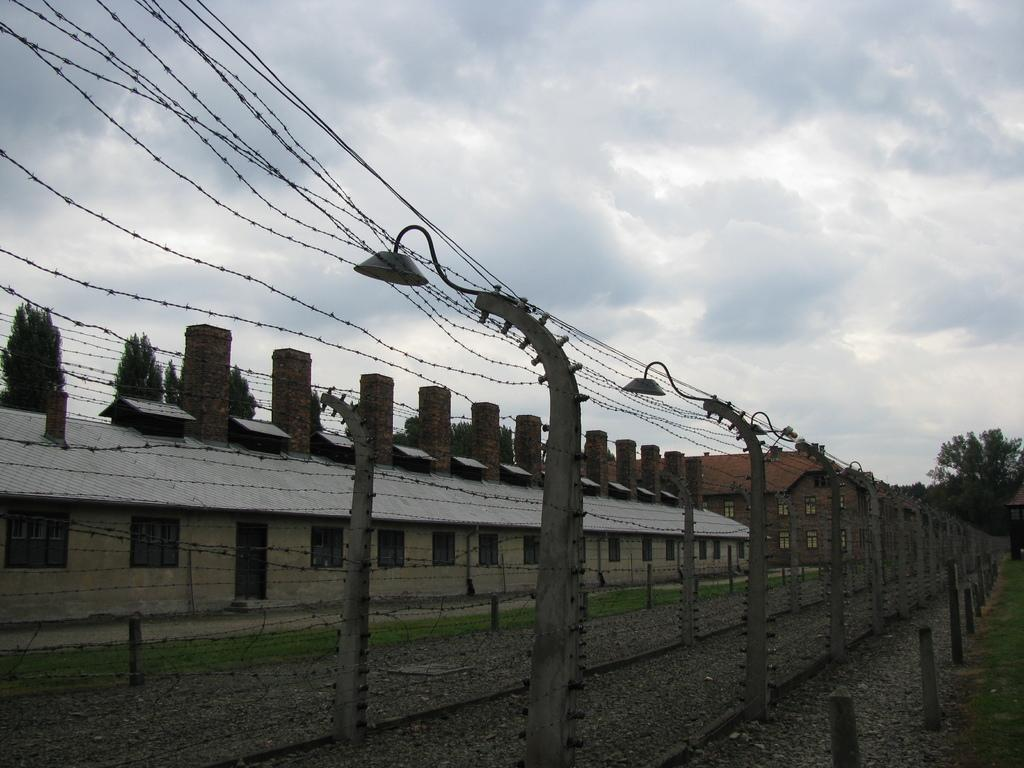What type of structure can be seen in the image? There is a fence in the image. What else can be seen in the image besides the fence? There are light poles, buildings, trees, and the sky visible in the image. Can you describe the objects on the ground in the background of the image? There are other objects on the ground in the background of the image, but their specific details are not mentioned in the provided facts. What does the mom think about the print in the image? There is no mention of a mom or a print in the image, so this question cannot be answered definitively. 